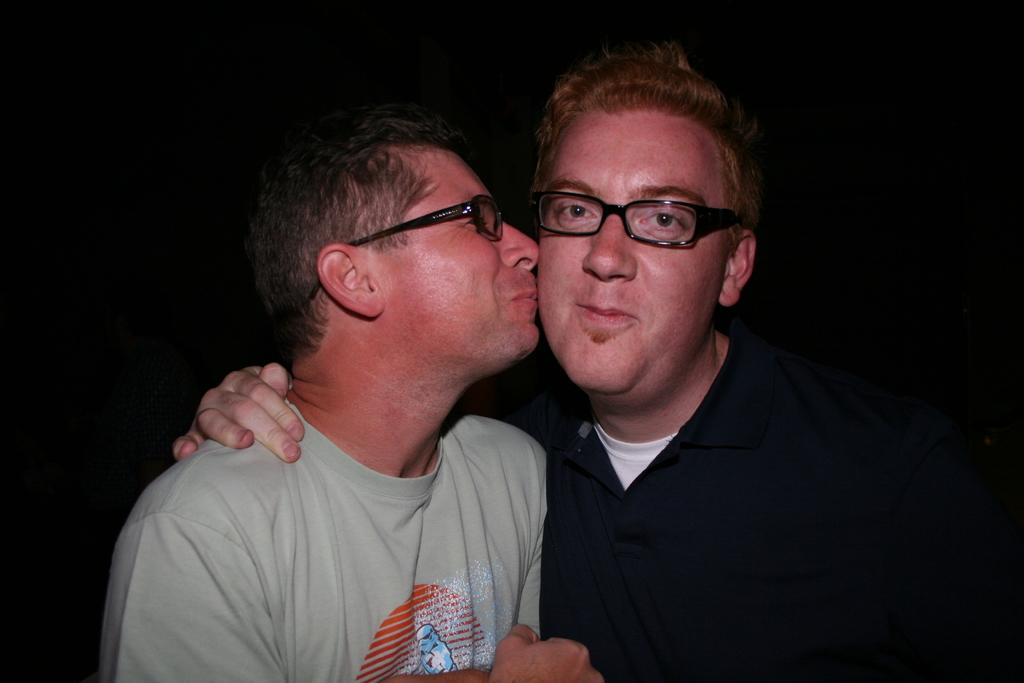How many people are in the image? There are two men in the image. What are the men wearing on their faces? Both men are wearing spectacles. What expression do the men have in the image? The men are smiling. What can be observed about the background of the image? The background of the image is dark. What type of substance is the men using to care for their cub in the image? There is no cub present in the image, and the men are not shown caring for any substance or object. 